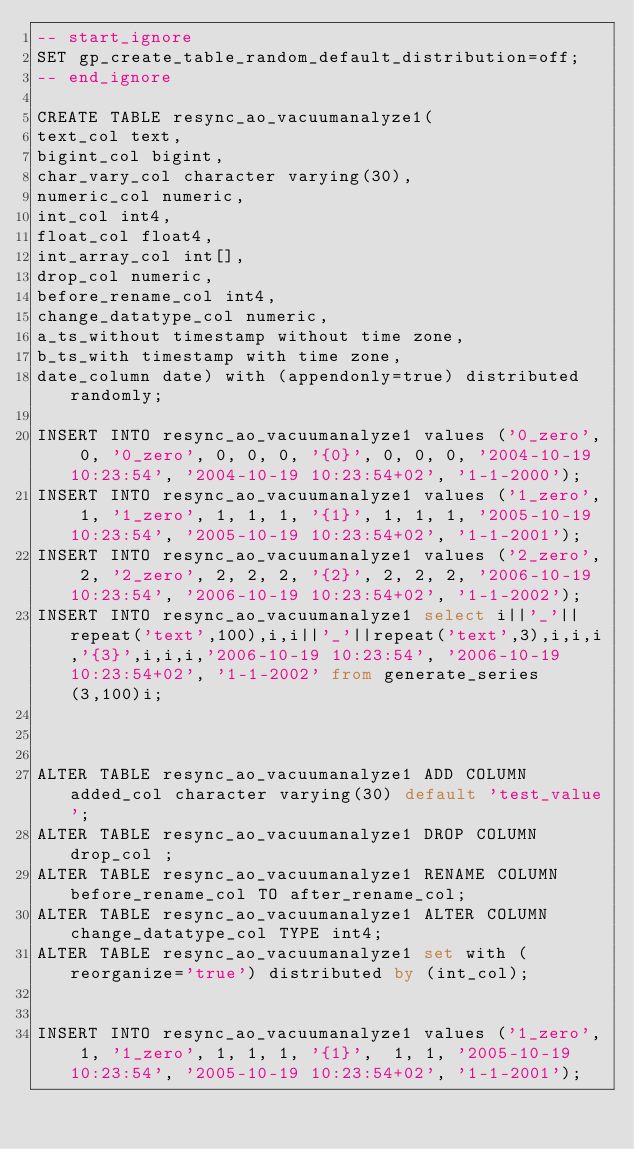<code> <loc_0><loc_0><loc_500><loc_500><_SQL_>-- start_ignore
SET gp_create_table_random_default_distribution=off;
-- end_ignore

CREATE TABLE resync_ao_vacuumanalyze1(
text_col text,
bigint_col bigint,
char_vary_col character varying(30),
numeric_col numeric,
int_col int4,
float_col float4,
int_array_col int[],
drop_col numeric,
before_rename_col int4,
change_datatype_col numeric,
a_ts_without timestamp without time zone,
b_ts_with timestamp with time zone,
date_column date) with (appendonly=true) distributed randomly;

INSERT INTO resync_ao_vacuumanalyze1 values ('0_zero', 0, '0_zero', 0, 0, 0, '{0}', 0, 0, 0, '2004-10-19 10:23:54', '2004-10-19 10:23:54+02', '1-1-2000');
INSERT INTO resync_ao_vacuumanalyze1 values ('1_zero', 1, '1_zero', 1, 1, 1, '{1}', 1, 1, 1, '2005-10-19 10:23:54', '2005-10-19 10:23:54+02', '1-1-2001');
INSERT INTO resync_ao_vacuumanalyze1 values ('2_zero', 2, '2_zero', 2, 2, 2, '{2}', 2, 2, 2, '2006-10-19 10:23:54', '2006-10-19 10:23:54+02', '1-1-2002');
INSERT INTO resync_ao_vacuumanalyze1 select i||'_'||repeat('text',100),i,i||'_'||repeat('text',3),i,i,i,'{3}',i,i,i,'2006-10-19 10:23:54', '2006-10-19 10:23:54+02', '1-1-2002' from generate_series(3,100)i;



ALTER TABLE resync_ao_vacuumanalyze1 ADD COLUMN added_col character varying(30) default 'test_value';
ALTER TABLE resync_ao_vacuumanalyze1 DROP COLUMN drop_col ;
ALTER TABLE resync_ao_vacuumanalyze1 RENAME COLUMN before_rename_col TO after_rename_col;
ALTER TABLE resync_ao_vacuumanalyze1 ALTER COLUMN change_datatype_col TYPE int4;
ALTER TABLE resync_ao_vacuumanalyze1 set with ( reorganize='true') distributed by (int_col);


INSERT INTO resync_ao_vacuumanalyze1 values ('1_zero', 1, '1_zero', 1, 1, 1, '{1}',  1, 1, '2005-10-19 10:23:54', '2005-10-19 10:23:54+02', '1-1-2001');</code> 